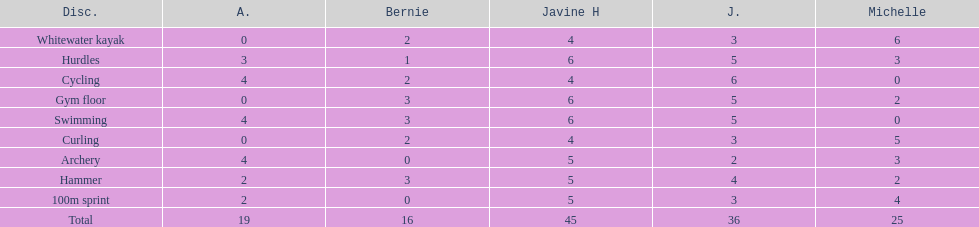What is the first discipline listed on this chart? Whitewater kayak. 